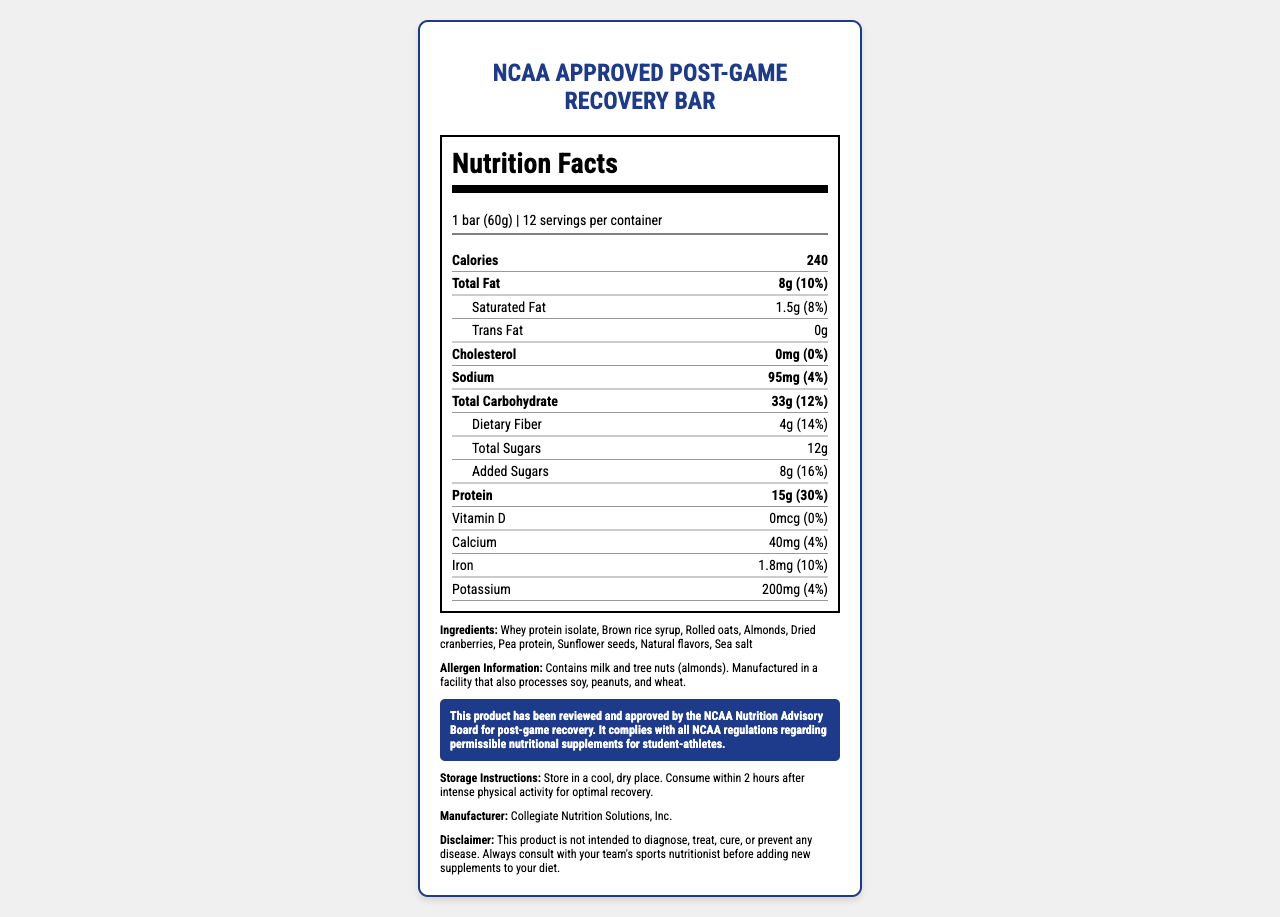what is the serving size of the recovery bar? The serving size is stated at the top of the Nutrition Facts section.
Answer: 1 bar (60g) how many calories are in one serving? The calories per serving are listed directly under the serving size information.
Answer: 240 compare the daily value percentages of total fat and protein. which is higher? Total Fat has a daily value percentage of 10%, while Protein has a daily value percentage of 30%. Therefore, the daily value percentage of Protein is higher.
Answer: Protein how many grams of dietary fiber are in one bar? The amount of dietary fiber per serving is listed under the Total Carbohydrate section.
Answer: 4g how much calcium does one serving of the bar contain? The calcium content is listed toward the bottom of the Nutrition Facts, under the micronutrient information.
Answer: 40mg which ingredient is listed first in the ingredients list? A. Brown rice syrup B. Whey protein isolate C. Almonds D. Dried cranberries The ingredients are listed in order of predominance, with Whey protein isolate being the first ingredient listed.
Answer: B. Whey protein isolate how many added sugars does the bar contain? A. 0g B. 4g C. 8g D. 12g The Added Sugars section lists 8g of added sugars.
Answer: C. 8g does the product contain dairy ingredients? The allergen information states that the product contains milk.
Answer: Yes what is the main purpose of the product according to the NCAA compliance statement? The NCAA compliance statement specifies that the product is approved for post-game recovery and complies with NCAA regulations.
Answer: Post-game recovery who manufactures the NCAA Approved Post-Game Recovery Bar? The manufacturer's information is listed at the bottom of the document.
Answer: Collegiate Nutrition Solutions, Inc. what are the storage instructions for this product? The storage instructions are provided clearly in a separate section of the document.
Answer: Store in a cool, dry place. Consume within 2 hours after intense physical activity for optimal recovery. does the product contain any trans fat? The Nutrition Facts section lists 0g of trans fat.
Answer: No how should you seek advice before adding this supplement to your diet? The disclaimer advises consultation with a sports nutritionist before adding new supplements to the diet.
Answer: Consult with your team's sports nutritionist how many servings are in one container? The number of servings per container is listed right after the serving size information.
Answer: 12 which ingredient is responsible for the protein content in the bar? Both Whey protein isolate and Pea protein are listed as ingredients and are known sources of protein.
Answer: Whey protein isolate and Pea protein describe the entire document. The document provides a detailed overview of the product's nutritional profile and other related information necessary for consumers, especially athletes, ensuring that it meets NCAA standards and is suitable for post-game recovery.
Answer: The document is a comprehensive Nutrition Facts label and description for the NCAA Approved Post-Game Recovery Bar. It includes information on serving size, number of servings per container, and detailed nutritional content such as calories, macronutrients, and micronutrients. It also lists all ingredients, allergen information, NCAA compliance statement, storage instructions, manufacturer details, and a disclaimer. what is the total carbohydrate content in the bar, including dietary fiber and total sugars? The total carbohydrate content is listed as 33g, encompassing dietary fiber and total sugars.
Answer: 33g can you determine the shelf life of the product from the document? The document does not provide any information regarding the shelf life of the product.
Answer: Cannot be determined 